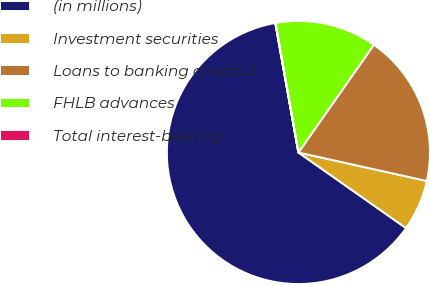Convert chart. <chart><loc_0><loc_0><loc_500><loc_500><pie_chart><fcel>(in millions)<fcel>Investment securities<fcel>Loans to banking clients 2<fcel>FHLB advances<fcel>Total interest-bearing<nl><fcel>62.43%<fcel>6.27%<fcel>18.75%<fcel>12.51%<fcel>0.03%<nl></chart> 